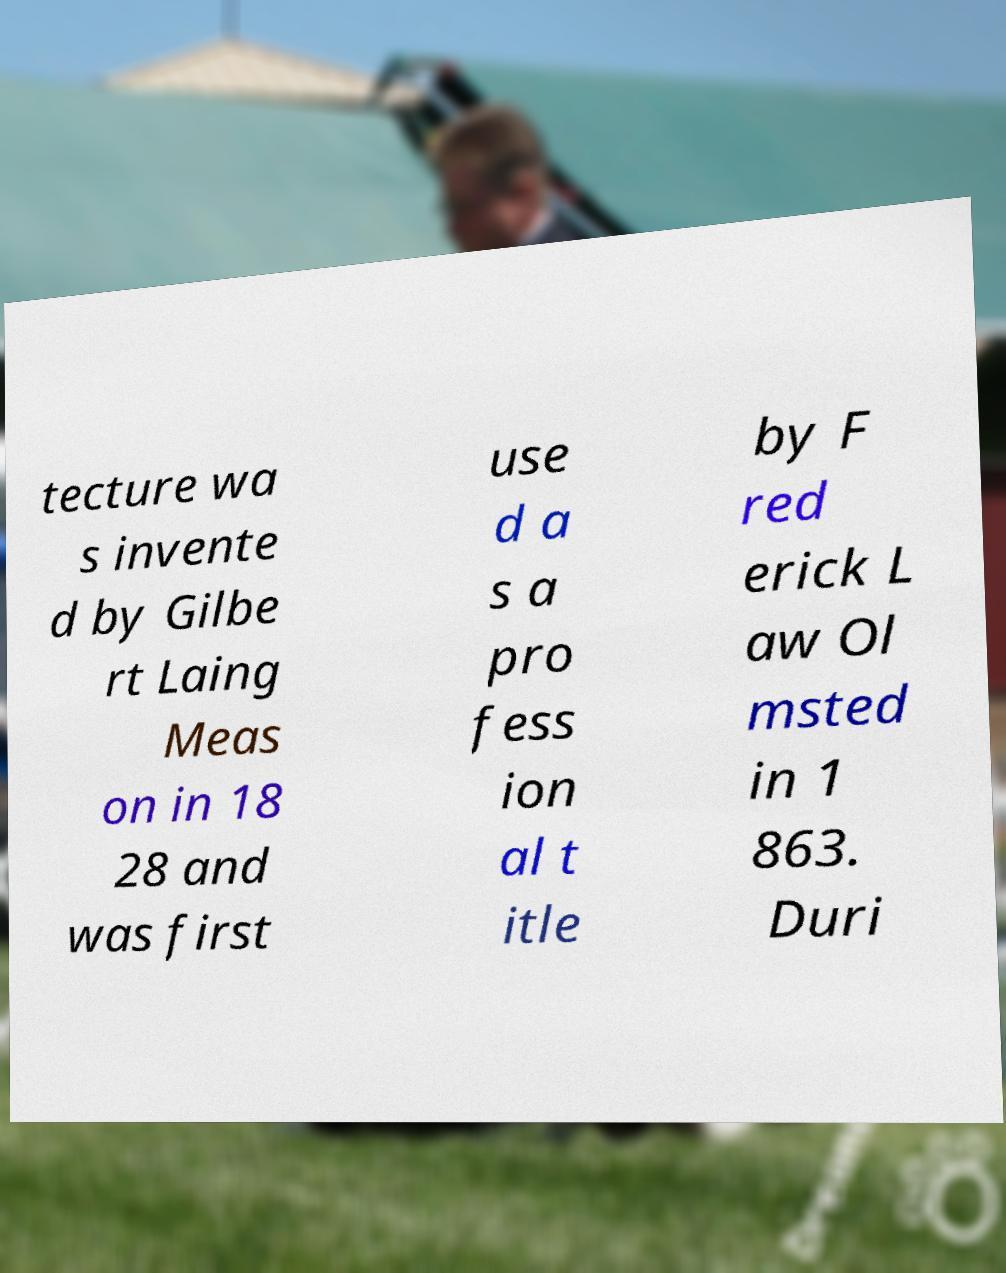Could you extract and type out the text from this image? tecture wa s invente d by Gilbe rt Laing Meas on in 18 28 and was first use d a s a pro fess ion al t itle by F red erick L aw Ol msted in 1 863. Duri 